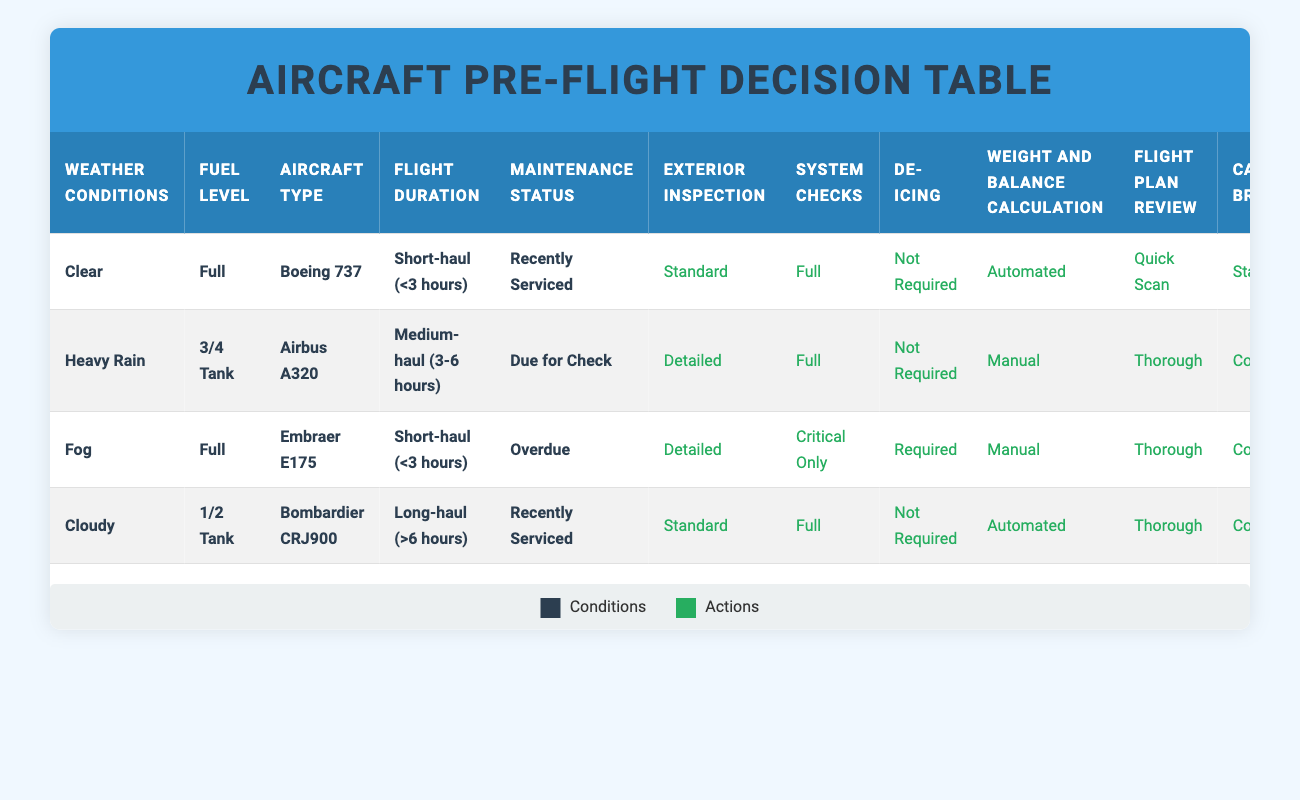What are the recommended actions when the weather is clear and the fuel level is full? According to the table, when the weather conditions are clear and the fuel level is full, the actions taken include: Exterior Inspection as Standard, System Checks as Full, De-icing as Not Required, Weight and Balance Calculation as Automated, Flight Plan Review as Quick Scan, and Cabin Crew Briefing as Standard.
Answer: Standard, Full, Not Required, Automated, Quick Scan, Standard Is de-icing required for the Embraer E175 when the maintenance status is overdue? The table indicates that for the Embraer E175 with a Full fuel level and Overdue maintenance status, de-icing is Required.
Answer: Yes How many different actions are taken when the weather conditions are heavy rain and fuel level is 3/4 tank? During heavy rain conditions with a 3/4 tank fuel level, the actions included: Exterior Inspection as Detailed, System Checks as Full, De-icing as Not Required, Weight and Balance Calculation as Manual, Flight Plan Review as Thorough, and Cabin Crew Briefing as Comprehensive. There are 6 actions in total.
Answer: 6 What is the difference in the type of Exterior Inspection recommended between clear weather and fog conditions? For clear weather, the Exterior Inspection is recommended as Standard. In contrast, for fog conditions, the Exterior Inspection is recommended as Detailed. The difference reflects the need for more thorough checks in fog.
Answer: Standard vs Detailed What is the action for Weight and Balance Calculation when flying a Bombardier CRJ900 for a long-haul flight? In the table, the action for Weight and Balance Calculation for a Bombardier CRJ900 during a long-haul flight (greater than 6 hours) is noted as Automated.
Answer: Automated If the fuel level is low, which maintenance status will trigger a Detailed Exterior Inspection? No specific entry in the table indicates a Detailed Exterior Inspection that aligns with a low fuel level. The existing conditions only show that a Detailed Inspection occurs under different circumstances. Thus, it is not directly linked to low fuel.
Answer: No Which aircraft type has the most comprehensive Cabin Crew Briefing requirement and under what conditions? The Airbus A320 requires a Comprehensive Cabin Crew Briefing under conditions of Heavy Rain, a 3/4 Tank fuel level, and Due for Check maintenance status. Thus, this aircraft type mandates the most thorough briefing.
Answer: Airbus A320 under Heavy Rain What are the conditions that lead to a Manual Weight and Balance Calculation? According to the rules, a Manual Weight and Balance Calculation is required under Heavy Rain with a 3/4 Tank in an Airbus A320, and under Fog with Full fuel in an Embraer E175 that has an Overdue maintenance status.
Answer: Heavy Rain, Fog Which condition has the least stringent de-icing requirement? For the Boeing 737 under clear weather and full fuel conditions, the de-icing requirement is Not Required, thus representing the least stringent condition.
Answer: Not Required 